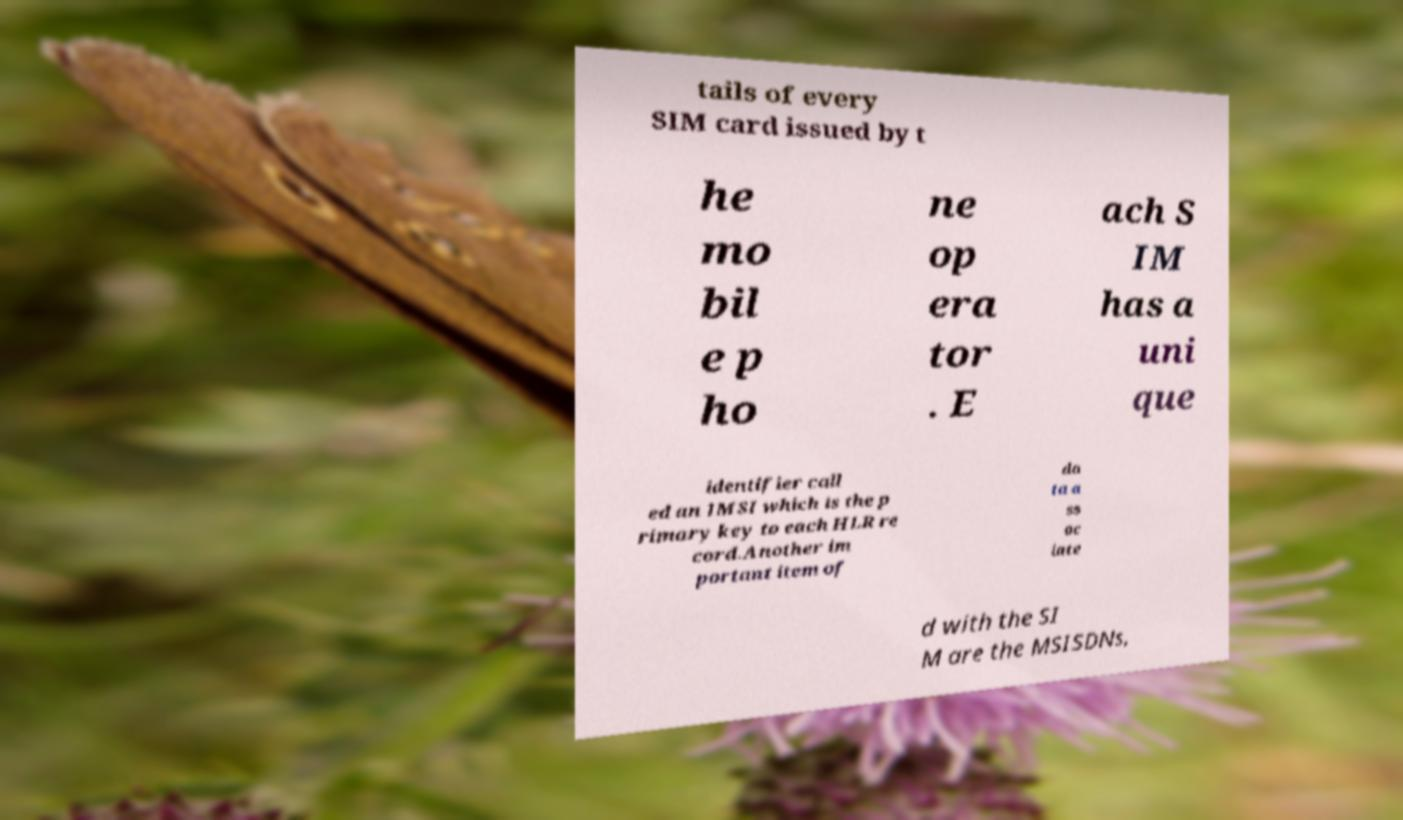There's text embedded in this image that I need extracted. Can you transcribe it verbatim? tails of every SIM card issued by t he mo bil e p ho ne op era tor . E ach S IM has a uni que identifier call ed an IMSI which is the p rimary key to each HLR re cord.Another im portant item of da ta a ss oc iate d with the SI M are the MSISDNs, 